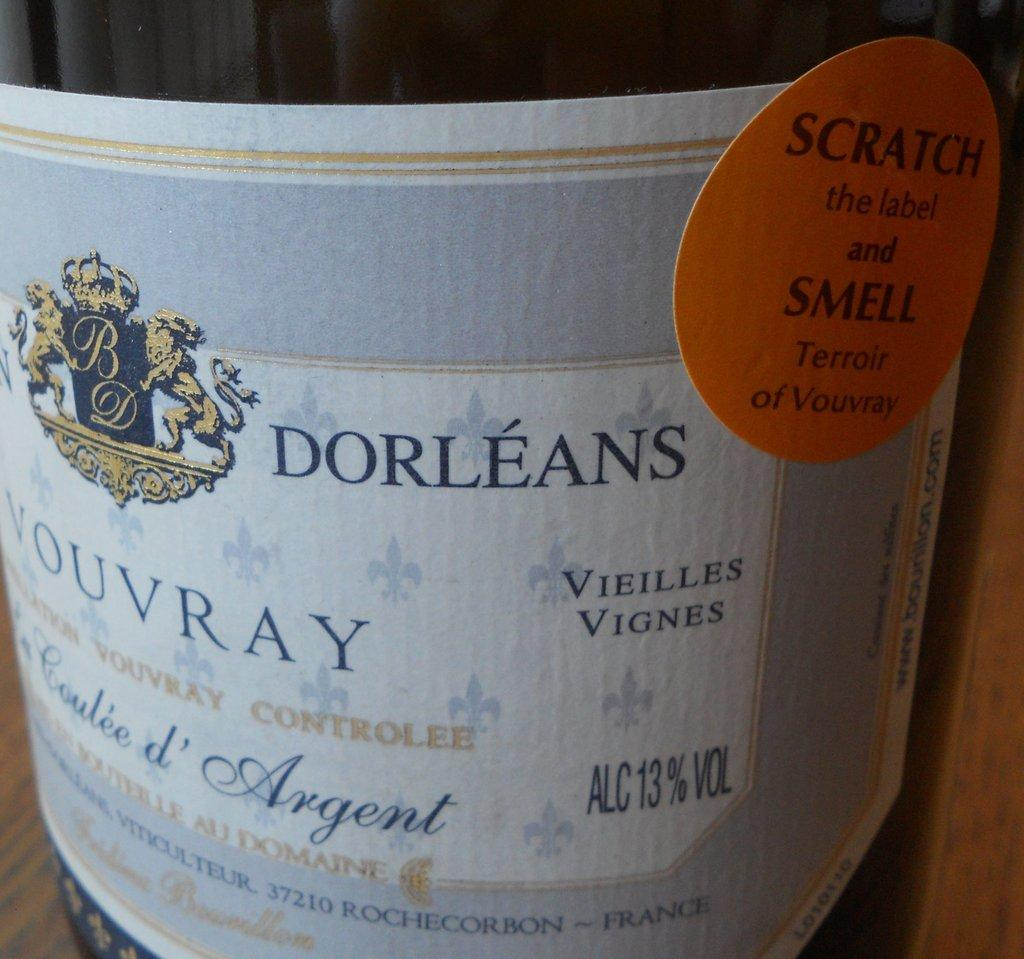<image>
Describe the image concisely. A orange sticker indicates that you can scratch it to smell the Terroir of Vouvray wine. 